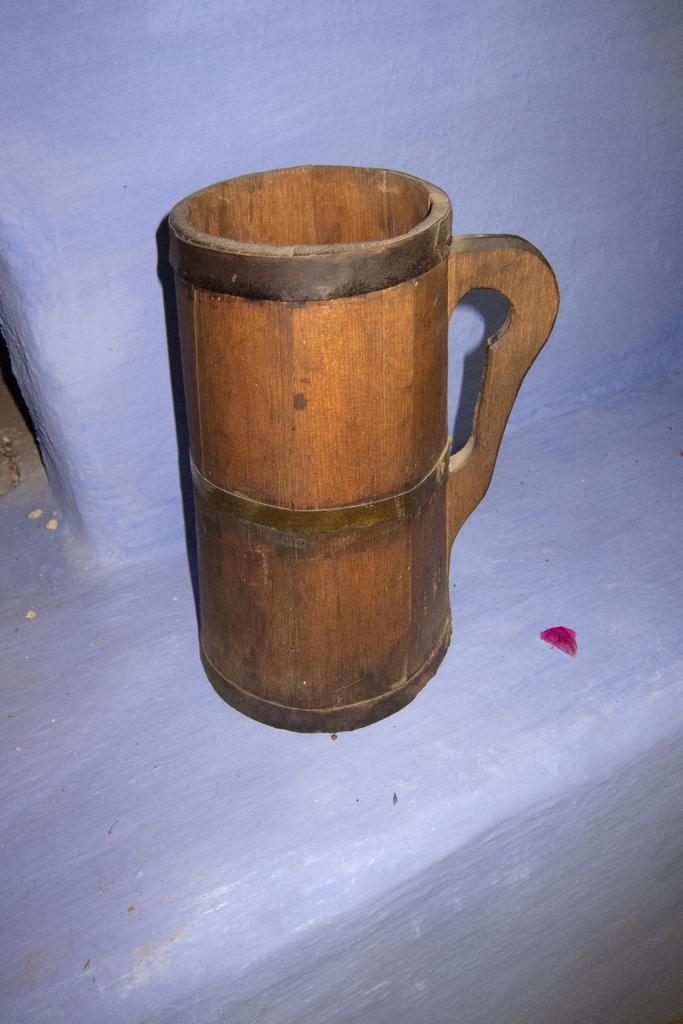Describe this image in one or two sentences. This is a zoomed in picture. In the center there is a wooden jug placed on the top of the blue color object. In the background we can see the blue color object seems to be the wall. 